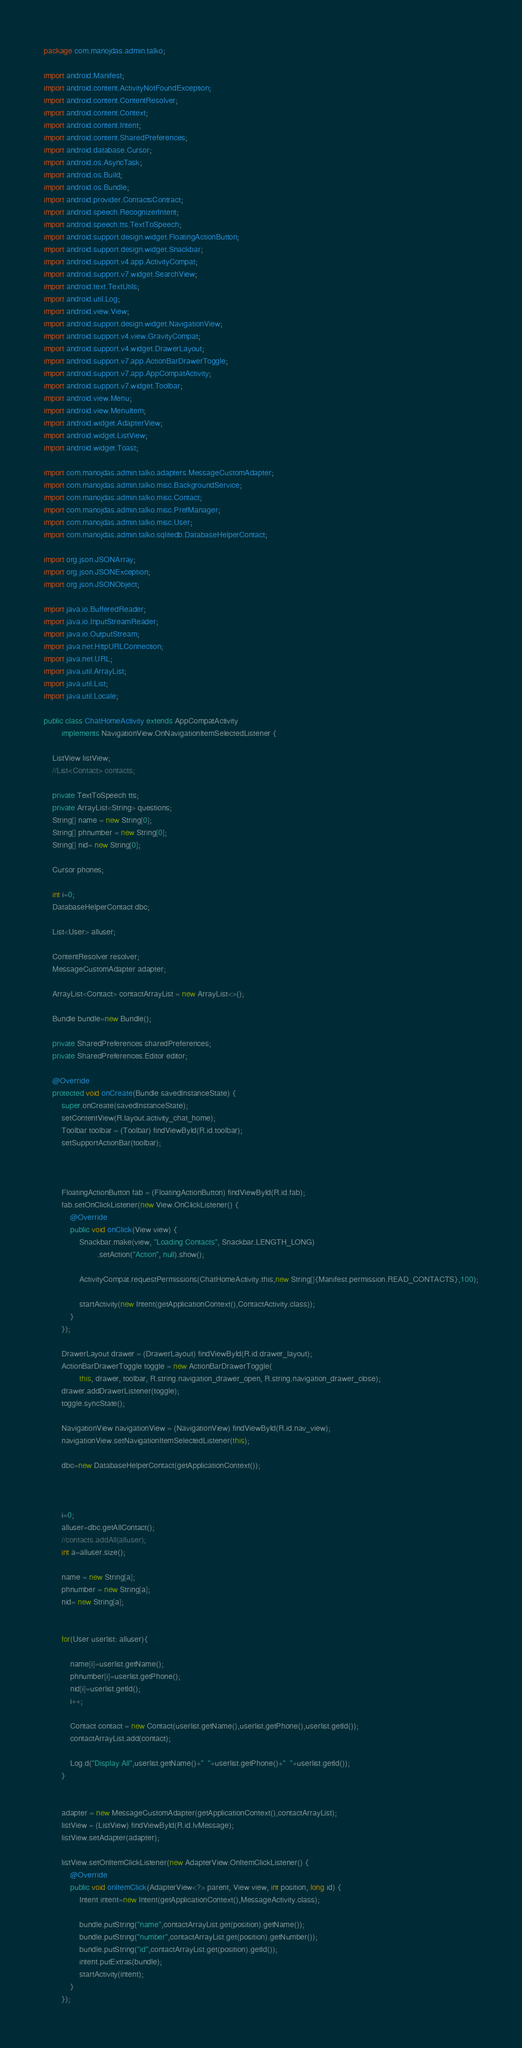<code> <loc_0><loc_0><loc_500><loc_500><_Java_>package com.manojdas.admin.talko;

import android.Manifest;
import android.content.ActivityNotFoundException;
import android.content.ContentResolver;
import android.content.Context;
import android.content.Intent;
import android.content.SharedPreferences;
import android.database.Cursor;
import android.os.AsyncTask;
import android.os.Build;
import android.os.Bundle;
import android.provider.ContactsContract;
import android.speech.RecognizerIntent;
import android.speech.tts.TextToSpeech;
import android.support.design.widget.FloatingActionButton;
import android.support.design.widget.Snackbar;
import android.support.v4.app.ActivityCompat;
import android.support.v7.widget.SearchView;
import android.text.TextUtils;
import android.util.Log;
import android.view.View;
import android.support.design.widget.NavigationView;
import android.support.v4.view.GravityCompat;
import android.support.v4.widget.DrawerLayout;
import android.support.v7.app.ActionBarDrawerToggle;
import android.support.v7.app.AppCompatActivity;
import android.support.v7.widget.Toolbar;
import android.view.Menu;
import android.view.MenuItem;
import android.widget.AdapterView;
import android.widget.ListView;
import android.widget.Toast;

import com.manojdas.admin.talko.adapters.MessageCustomAdapter;
import com.manojdas.admin.talko.misc.BackgroundService;
import com.manojdas.admin.talko.misc.Contact;
import com.manojdas.admin.talko.misc.PrefManager;
import com.manojdas.admin.talko.misc.User;
import com.manojdas.admin.talko.sqlitedb.DatabaseHelperContact;

import org.json.JSONArray;
import org.json.JSONException;
import org.json.JSONObject;

import java.io.BufferedReader;
import java.io.InputStreamReader;
import java.io.OutputStream;
import java.net.HttpURLConnection;
import java.net.URL;
import java.util.ArrayList;
import java.util.List;
import java.util.Locale;

public class ChatHomeActivity extends AppCompatActivity
        implements NavigationView.OnNavigationItemSelectedListener {

    ListView listView;
    //List<Contact> contacts;

    private TextToSpeech tts;
    private ArrayList<String> questions;
    String[] name = new String[0];
    String[] phnumber = new String[0];
    String[] nid= new String[0];

    Cursor phones;

    int i=0;
    DatabaseHelperContact dbc;

    List<User> alluser;

    ContentResolver resolver;
    MessageCustomAdapter adapter;

    ArrayList<Contact> contactArrayList = new ArrayList<>();

    Bundle bundle=new Bundle();

    private SharedPreferences sharedPreferences;
    private SharedPreferences.Editor editor;

    @Override
    protected void onCreate(Bundle savedInstanceState) {
        super.onCreate(savedInstanceState);
        setContentView(R.layout.activity_chat_home);
        Toolbar toolbar = (Toolbar) findViewById(R.id.toolbar);
        setSupportActionBar(toolbar);



        FloatingActionButton fab = (FloatingActionButton) findViewById(R.id.fab);
        fab.setOnClickListener(new View.OnClickListener() {
            @Override
            public void onClick(View view) {
                Snackbar.make(view, "Loading Contacts", Snackbar.LENGTH_LONG)
                        .setAction("Action", null).show();

                ActivityCompat.requestPermissions(ChatHomeActivity.this,new String[]{Manifest.permission.READ_CONTACTS},100);

                startActivity(new Intent(getApplicationContext(),ContactActivity.class));
            }
        });

        DrawerLayout drawer = (DrawerLayout) findViewById(R.id.drawer_layout);
        ActionBarDrawerToggle toggle = new ActionBarDrawerToggle(
                this, drawer, toolbar, R.string.navigation_drawer_open, R.string.navigation_drawer_close);
        drawer.addDrawerListener(toggle);
        toggle.syncState();

        NavigationView navigationView = (NavigationView) findViewById(R.id.nav_view);
        navigationView.setNavigationItemSelectedListener(this);

        dbc=new DatabaseHelperContact(getApplicationContext());



        i=0;
        alluser=dbc.getAllContact();
        //contacts.addAll(alluser);
        int a=alluser.size();

        name = new String[a];
        phnumber = new String[a];
        nid= new String[a];


        for(User userlist: alluser){

            name[i]=userlist.getName();
            phnumber[i]=userlist.getPhone();
            nid[i]=userlist.getId();
            i++;

            Contact contact = new Contact(userlist.getName(),userlist.getPhone(),userlist.getId());
            contactArrayList.add(contact);

            Log.d("Display All",userlist.getName()+"  "+userlist.getPhone()+"  "+userlist.getId());
        }


        adapter = new MessageCustomAdapter(getApplicationContext(),contactArrayList);
        listView = (ListView) findViewById(R.id.lvMessage);
        listView.setAdapter(adapter);

        listView.setOnItemClickListener(new AdapterView.OnItemClickListener() {
            @Override
            public void onItemClick(AdapterView<?> parent, View view, int position, long id) {
                Intent intent=new Intent(getApplicationContext(),MessageActivity.class);

                bundle.putString("name",contactArrayList.get(position).getName());
                bundle.putString("number",contactArrayList.get(position).getNumber());
                bundle.putString("id",contactArrayList.get(position).getId());
                intent.putExtras(bundle);
                startActivity(intent);
            }
        });


</code> 